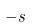<formula> <loc_0><loc_0><loc_500><loc_500>- s</formula> 